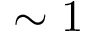<formula> <loc_0><loc_0><loc_500><loc_500>\sim 1</formula> 